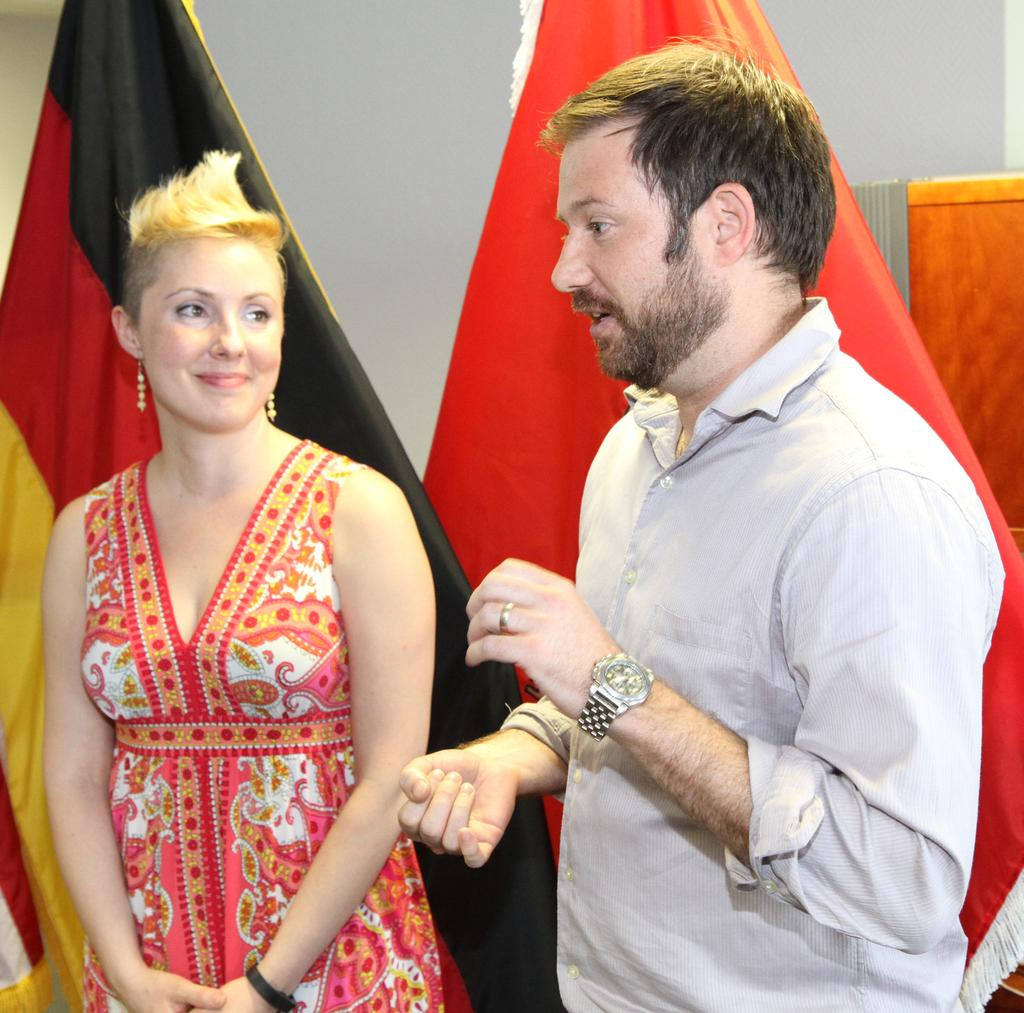How many people are present in the image? There are two people in the image. What can be seen in the background of the image? There are flags and a wall in the background of the image. What type of hole can be seen in the stocking of the person in the image? There is no person wearing a stocking in the image, and therefore no hole can be observed. 